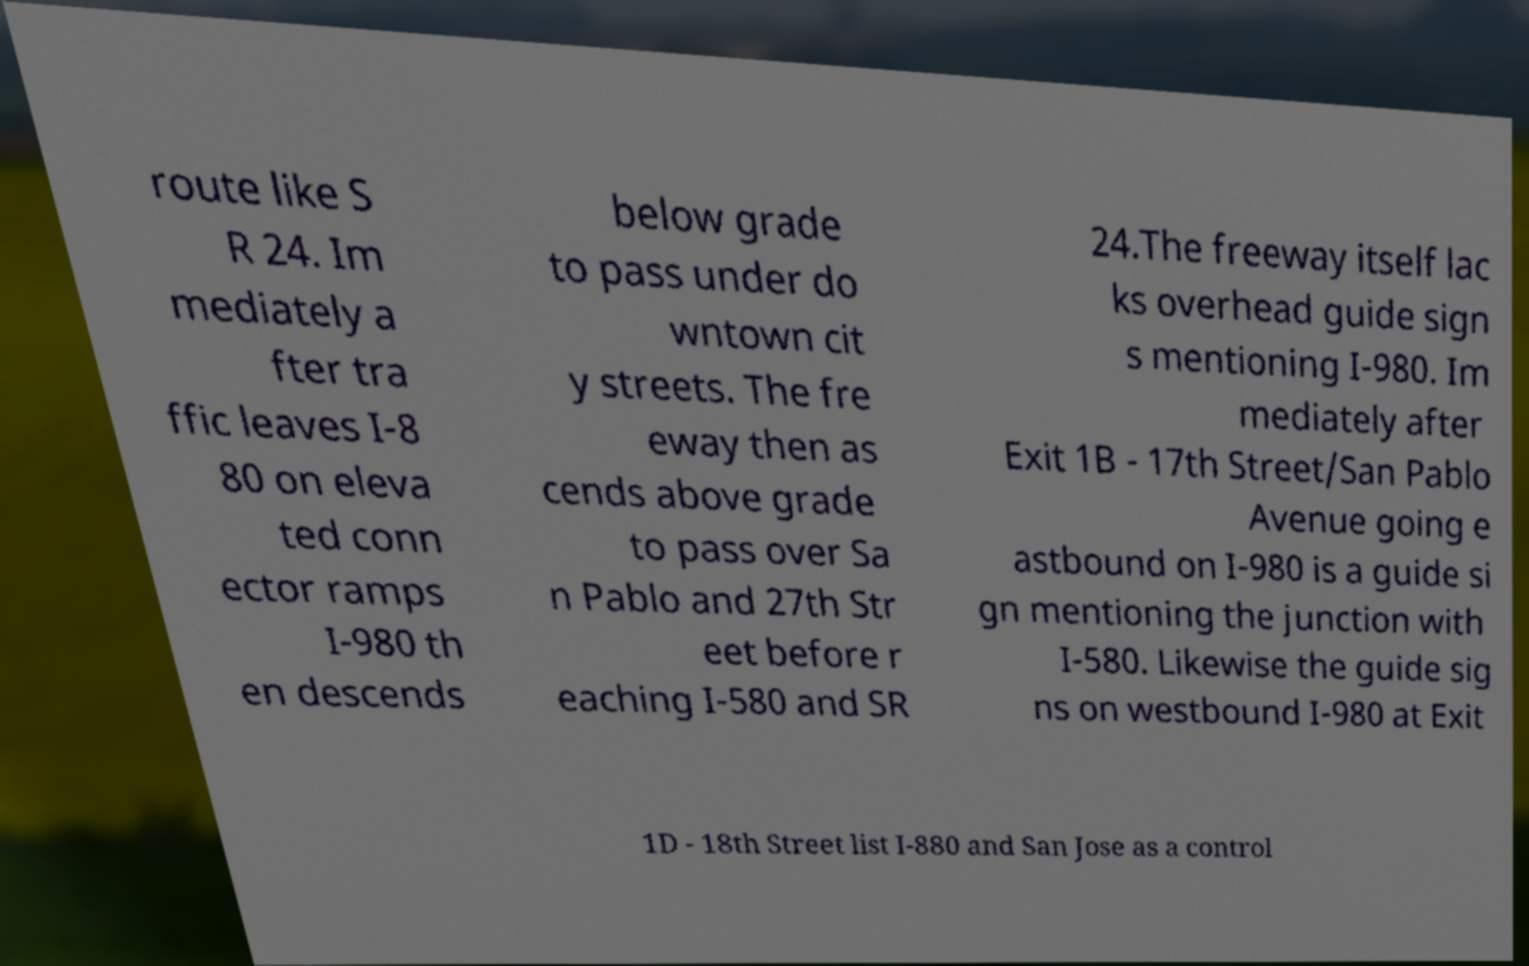Can you accurately transcribe the text from the provided image for me? route like S R 24. Im mediately a fter tra ffic leaves I-8 80 on eleva ted conn ector ramps I-980 th en descends below grade to pass under do wntown cit y streets. The fre eway then as cends above grade to pass over Sa n Pablo and 27th Str eet before r eaching I-580 and SR 24.The freeway itself lac ks overhead guide sign s mentioning I-980. Im mediately after Exit 1B - 17th Street/San Pablo Avenue going e astbound on I-980 is a guide si gn mentioning the junction with I-580. Likewise the guide sig ns on westbound I-980 at Exit 1D - 18th Street list I-880 and San Jose as a control 